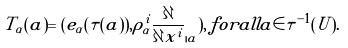<formula> <loc_0><loc_0><loc_500><loc_500>\tilde { T } _ { \alpha } ( a ) = ( e _ { \alpha } ( \tau ( a ) ) , \rho _ { \alpha } ^ { i } \frac { \partial } { \partial x ^ { i } } _ { | a } ) , \, f o r a l l a \in \tau ^ { - 1 } ( U ) .</formula> 